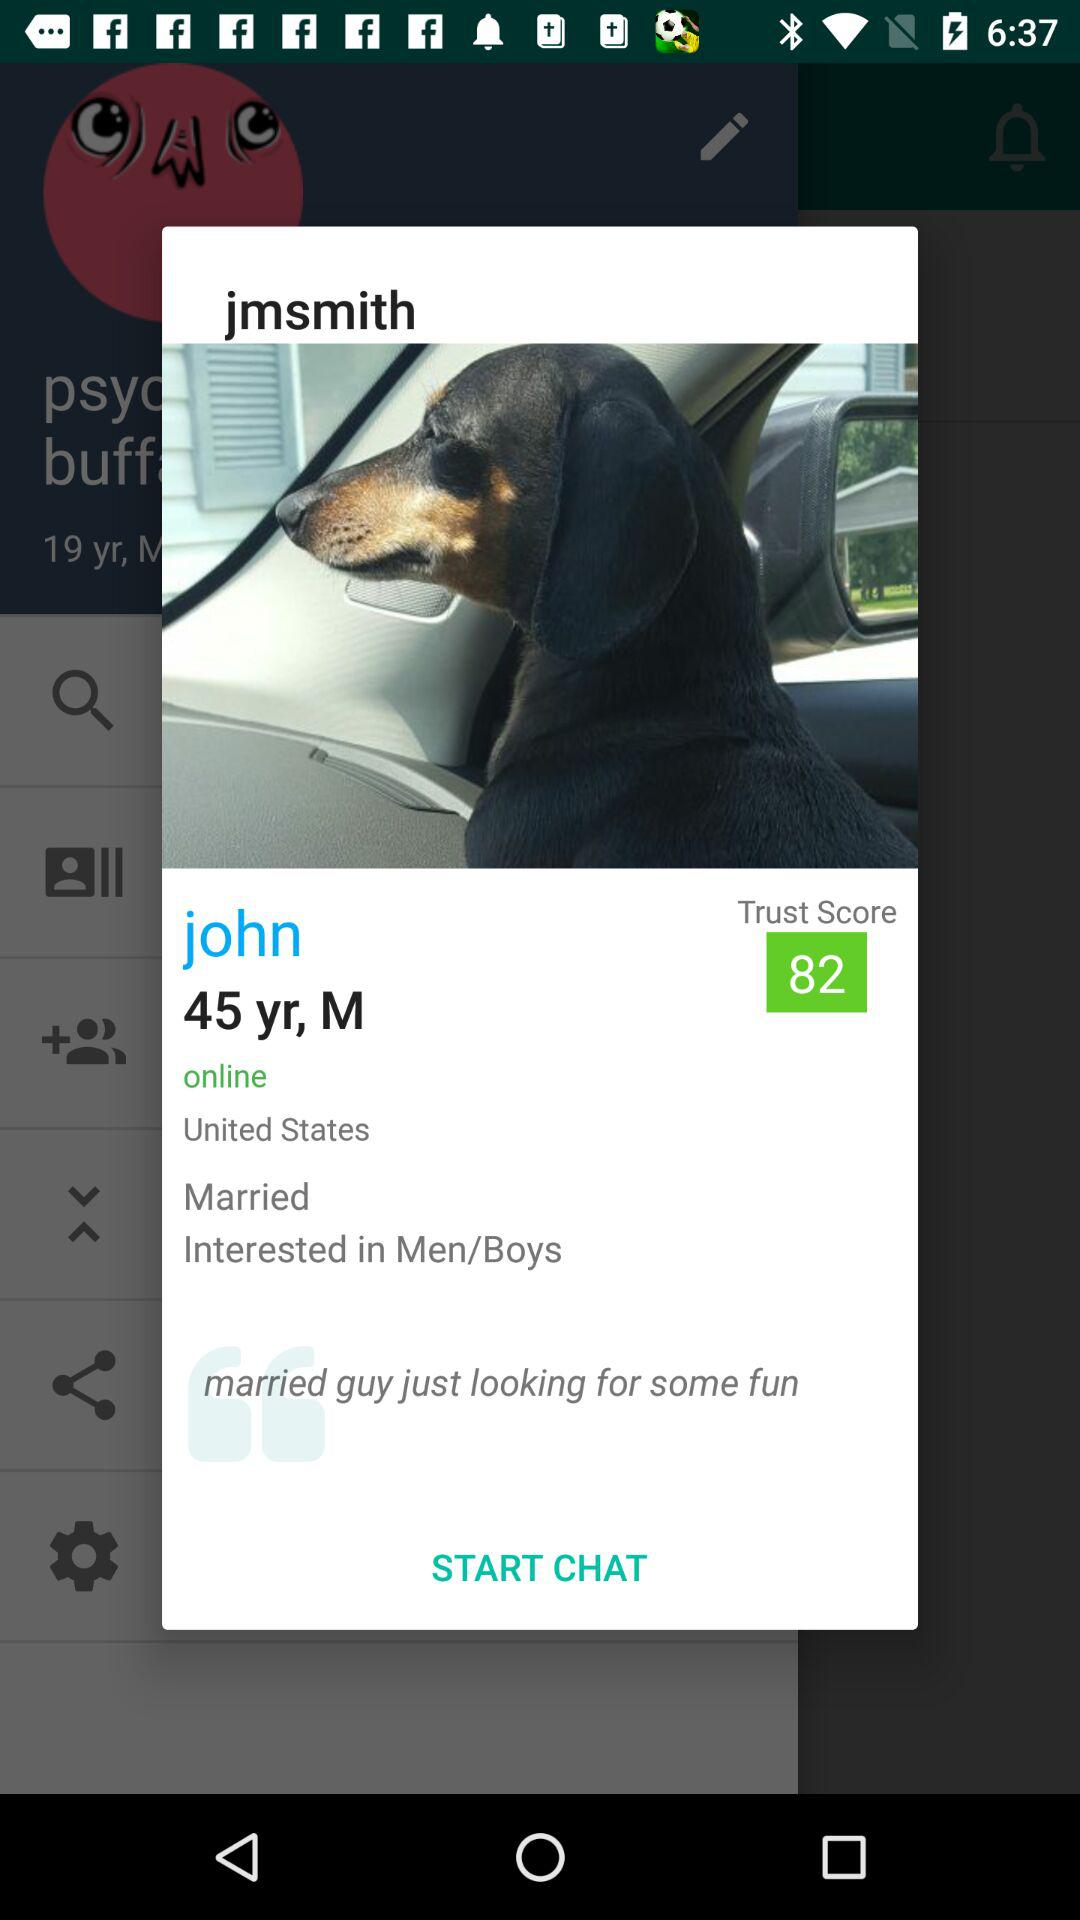What is the mentioned location? The mentioned location is the "United States". 